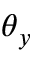<formula> <loc_0><loc_0><loc_500><loc_500>\theta _ { y }</formula> 